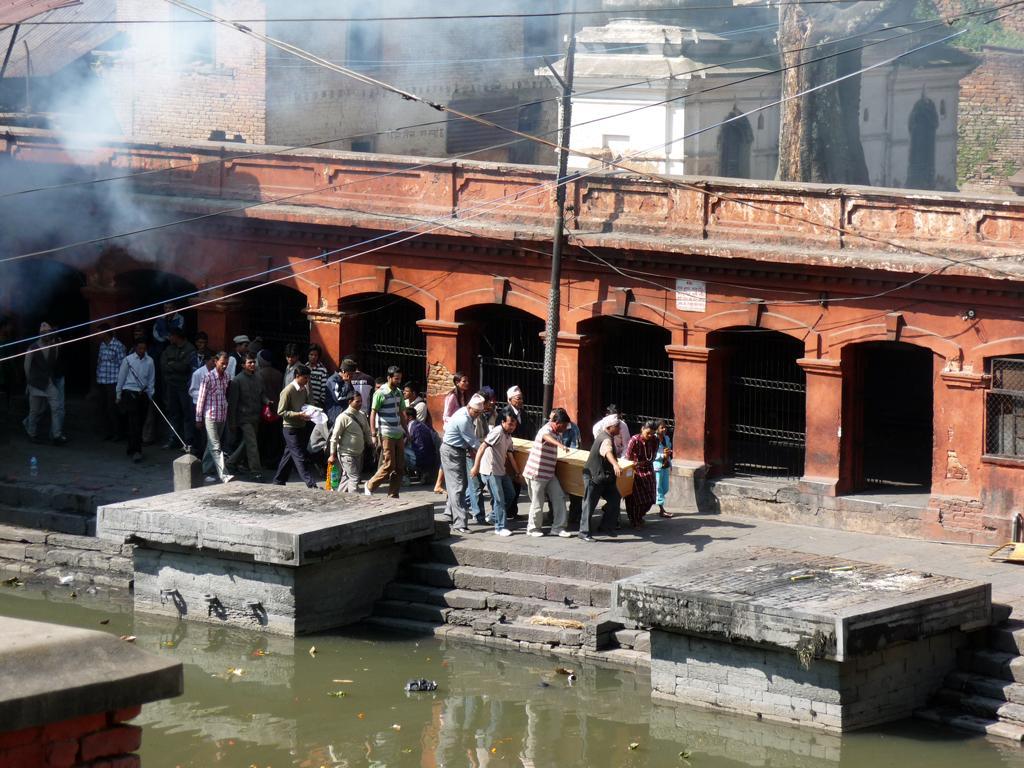In one or two sentences, can you explain what this image depicts? In this picture there is a water at the bottom side of the image and there are people in the center of the image, by holding box in there hands and there is a pole and arches behind them and there are buildings and trees at the top side of the image. 